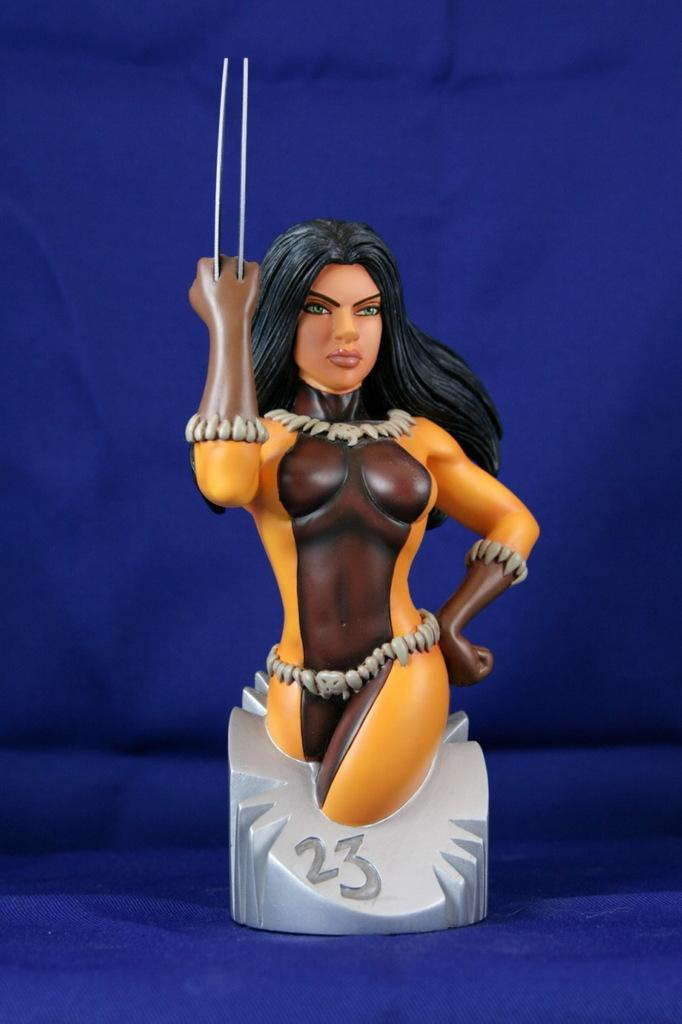What object can be seen in the image? There is a toy in the image. Where is the toy located? The toy is on a platform. What color is the background of the image? The background of the image is blue. What type of receipt is visible in the image? There is no receipt present in the image. How is the toy connected to the chain in the image? There is no chain present in the image, and the toy is not connected to one. 